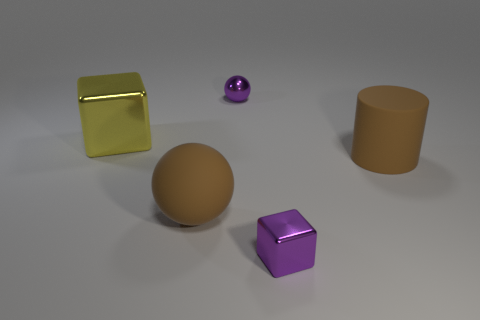Add 3 large metallic blocks. How many objects exist? 8 Subtract all spheres. How many objects are left? 3 Add 5 tiny shiny cubes. How many tiny shiny cubes exist? 6 Subtract 0 cyan cubes. How many objects are left? 5 Subtract all brown cubes. Subtract all yellow metal things. How many objects are left? 4 Add 2 rubber spheres. How many rubber spheres are left? 3 